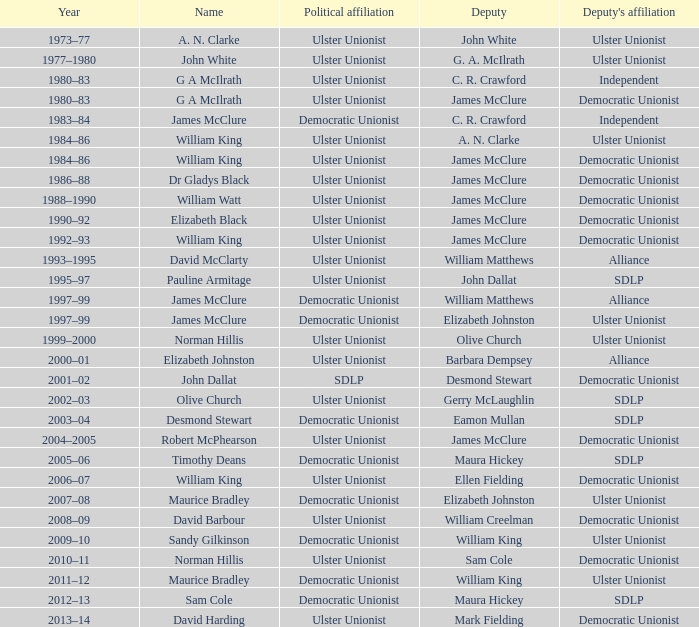During the 1992-93 period, who was the deputy? James McClure. 